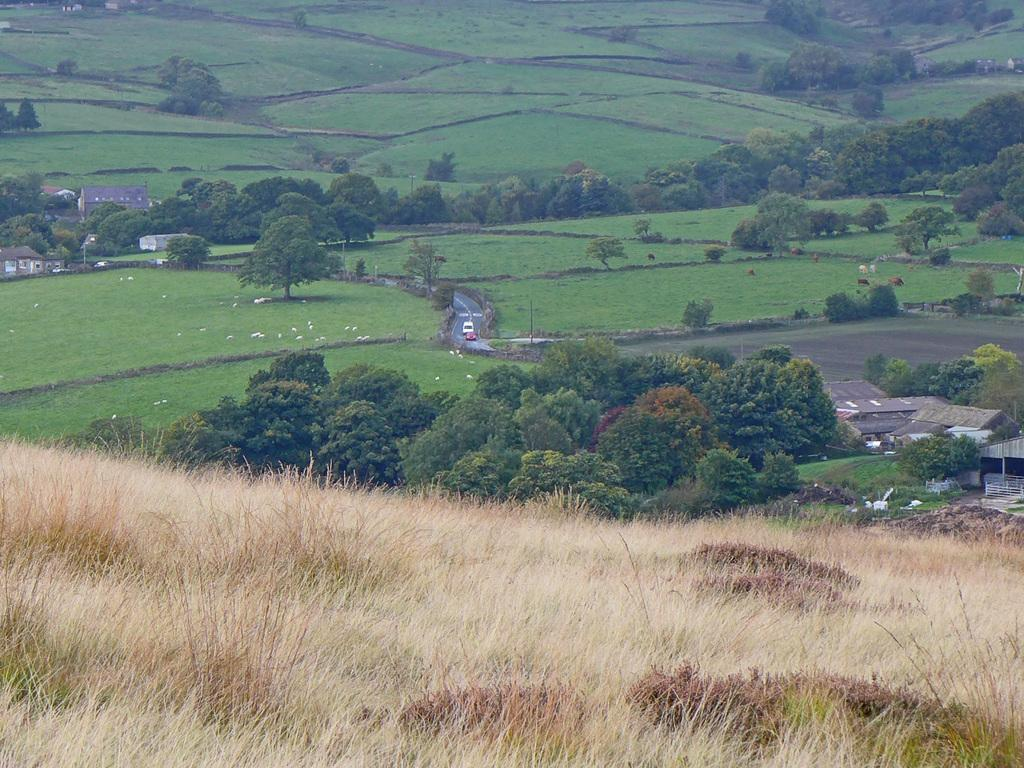What can be seen on the ground in the image? There are vehicles and animals on the ground in the image. What type of vegetation is visible in the image? There is grass visible in the image. What type of structures are present in the image? There are houses with roofs in the image. What natural feature is present in the image? There is a group of trees in the image. Where is the lunchroom located in the image? There is no lunchroom present in the image. How much salt is visible on the ground in the image? There is no salt visible on the ground in the image. 